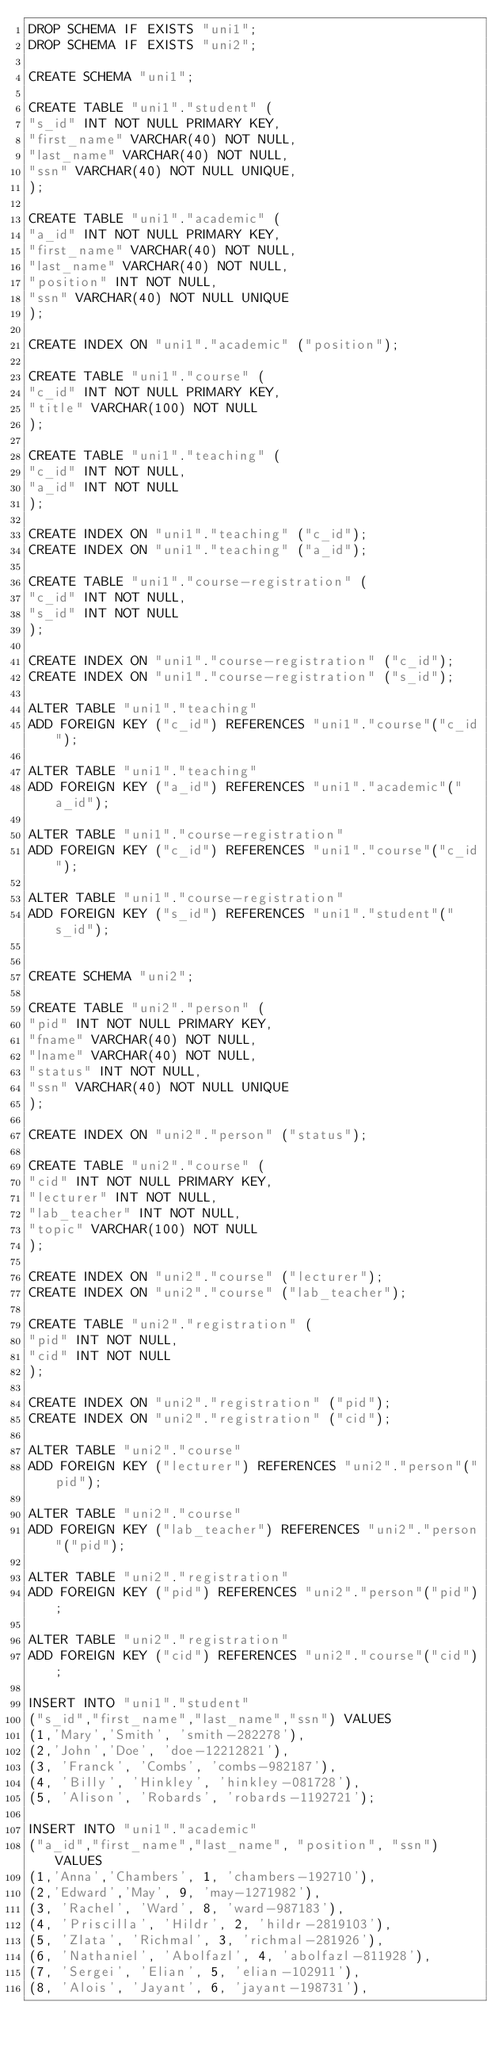<code> <loc_0><loc_0><loc_500><loc_500><_SQL_>DROP SCHEMA IF EXISTS "uni1";
DROP SCHEMA IF EXISTS "uni2";

CREATE SCHEMA "uni1";

CREATE TABLE "uni1"."student" (
"s_id" INT NOT NULL PRIMARY KEY,
"first_name" VARCHAR(40) NOT NULL,
"last_name" VARCHAR(40) NOT NULL,
"ssn" VARCHAR(40) NOT NULL UNIQUE,
);

CREATE TABLE "uni1"."academic" (
"a_id" INT NOT NULL PRIMARY KEY,
"first_name" VARCHAR(40) NOT NULL,
"last_name" VARCHAR(40) NOT NULL,
"position" INT NOT NULL,
"ssn" VARCHAR(40) NOT NULL UNIQUE
);

CREATE INDEX ON "uni1"."academic" ("position");

CREATE TABLE "uni1"."course" (
"c_id" INT NOT NULL PRIMARY KEY,
"title" VARCHAR(100) NOT NULL
);

CREATE TABLE "uni1"."teaching" (
"c_id" INT NOT NULL,
"a_id" INT NOT NULL
);

CREATE INDEX ON "uni1"."teaching" ("c_id");
CREATE INDEX ON "uni1"."teaching" ("a_id");

CREATE TABLE "uni1"."course-registration" (
"c_id" INT NOT NULL,
"s_id" INT NOT NULL
);

CREATE INDEX ON "uni1"."course-registration" ("c_id");
CREATE INDEX ON "uni1"."course-registration" ("s_id");

ALTER TABLE "uni1"."teaching"
ADD FOREIGN KEY ("c_id") REFERENCES "uni1"."course"("c_id");

ALTER TABLE "uni1"."teaching"
ADD FOREIGN KEY ("a_id") REFERENCES "uni1"."academic"("a_id");

ALTER TABLE "uni1"."course-registration"
ADD FOREIGN KEY ("c_id") REFERENCES "uni1"."course"("c_id");

ALTER TABLE "uni1"."course-registration"
ADD FOREIGN KEY ("s_id") REFERENCES "uni1"."student"("s_id");


CREATE SCHEMA "uni2";

CREATE TABLE "uni2"."person" (
"pid" INT NOT NULL PRIMARY KEY,
"fname" VARCHAR(40) NOT NULL,
"lname" VARCHAR(40) NOT NULL,
"status" INT NOT NULL,
"ssn" VARCHAR(40) NOT NULL UNIQUE
);

CREATE INDEX ON "uni2"."person" ("status");

CREATE TABLE "uni2"."course" (
"cid" INT NOT NULL PRIMARY KEY,
"lecturer" INT NOT NULL,
"lab_teacher" INT NOT NULL,
"topic" VARCHAR(100) NOT NULL
);

CREATE INDEX ON "uni2"."course" ("lecturer");
CREATE INDEX ON "uni2"."course" ("lab_teacher");

CREATE TABLE "uni2"."registration" (
"pid" INT NOT NULL,
"cid" INT NOT NULL
);

CREATE INDEX ON "uni2"."registration" ("pid");
CREATE INDEX ON "uni2"."registration" ("cid");

ALTER TABLE "uni2"."course"
ADD FOREIGN KEY ("lecturer") REFERENCES "uni2"."person"("pid");

ALTER TABLE "uni2"."course"
ADD FOREIGN KEY ("lab_teacher") REFERENCES "uni2"."person"("pid");

ALTER TABLE "uni2"."registration"
ADD FOREIGN KEY ("pid") REFERENCES "uni2"."person"("pid");

ALTER TABLE "uni2"."registration"
ADD FOREIGN KEY ("cid") REFERENCES "uni2"."course"("cid");

INSERT INTO "uni1"."student"
("s_id","first_name","last_name","ssn") VALUES
(1,'Mary','Smith', 'smith-282278'),
(2,'John','Doe', 'doe-12212821'),
(3, 'Franck', 'Combs', 'combs-982187'),
(4, 'Billy', 'Hinkley', 'hinkley-081728'),
(5, 'Alison', 'Robards', 'robards-1192721');

INSERT INTO "uni1"."academic"
("a_id","first_name","last_name", "position", "ssn") VALUES
(1,'Anna','Chambers', 1, 'chambers-192710'),
(2,'Edward','May', 9, 'may-1271982'),
(3, 'Rachel', 'Ward', 8, 'ward-987183'),
(4, 'Priscilla', 'Hildr', 2, 'hildr-2819103'),
(5, 'Zlata', 'Richmal', 3, 'richmal-281926'),
(6, 'Nathaniel', 'Abolfazl', 4, 'abolfazl-811928'),
(7, 'Sergei', 'Elian', 5, 'elian-102911'),
(8, 'Alois', 'Jayant', 6, 'jayant-198731'),</code> 